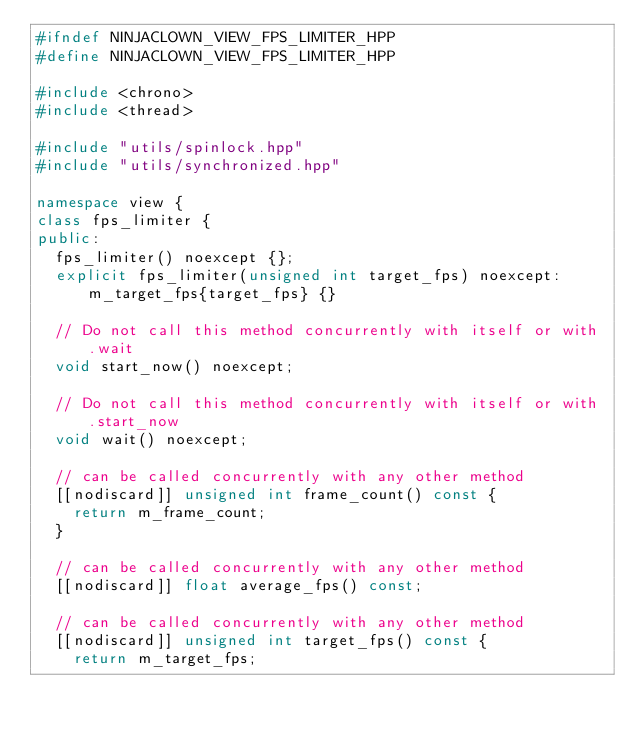Convert code to text. <code><loc_0><loc_0><loc_500><loc_500><_C++_>#ifndef NINJACLOWN_VIEW_FPS_LIMITER_HPP
#define NINJACLOWN_VIEW_FPS_LIMITER_HPP

#include <chrono>
#include <thread>

#include "utils/spinlock.hpp"
#include "utils/synchronized.hpp"

namespace view {
class fps_limiter {
public:
	fps_limiter() noexcept {};
	explicit fps_limiter(unsigned int target_fps) noexcept: m_target_fps{target_fps} {}

	// Do not call this method concurrently with itself or with .wait
	void start_now() noexcept;

	// Do not call this method concurrently with itself or with .start_now
	void wait() noexcept;

	// can be called concurrently with any other method
	[[nodiscard]] unsigned int frame_count() const {
		return m_frame_count;
	}

	// can be called concurrently with any other method
	[[nodiscard]] float average_fps() const;

	// can be called concurrently with any other method
	[[nodiscard]] unsigned int target_fps() const {
		return m_target_fps;</code> 